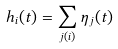Convert formula to latex. <formula><loc_0><loc_0><loc_500><loc_500>h _ { i } ( t ) = \sum _ { j ( i ) } { \eta _ { j } ( t ) }</formula> 